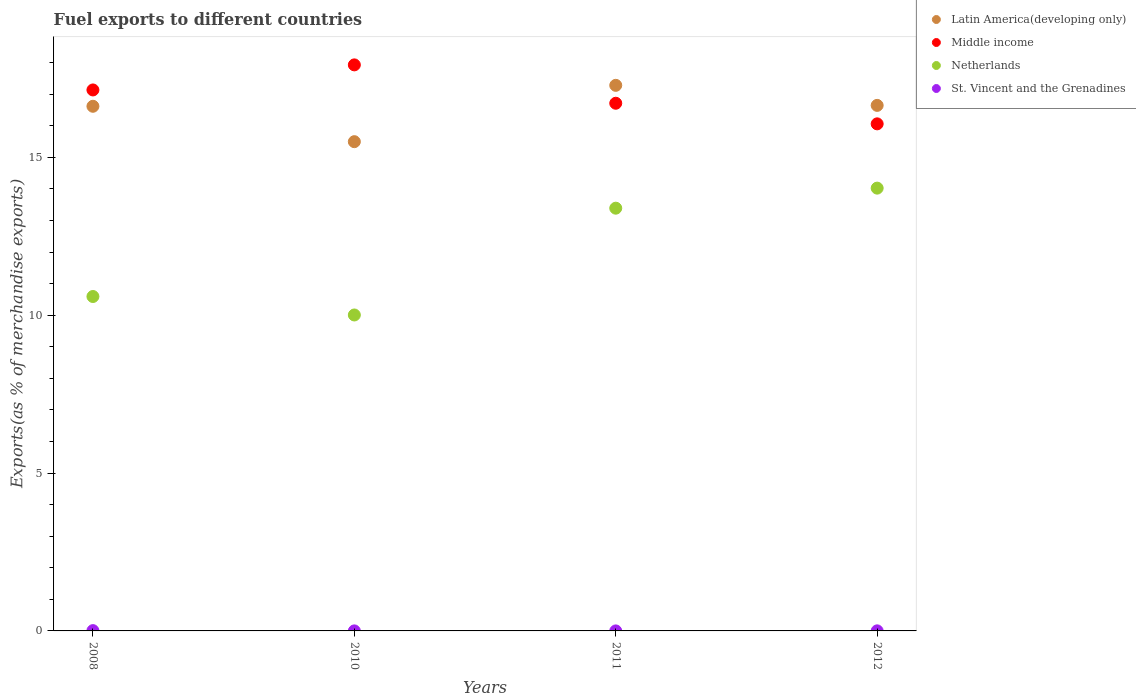What is the percentage of exports to different countries in Netherlands in 2011?
Make the answer very short. 13.39. Across all years, what is the maximum percentage of exports to different countries in Netherlands?
Your answer should be compact. 14.03. Across all years, what is the minimum percentage of exports to different countries in St. Vincent and the Grenadines?
Provide a succinct answer. 0. What is the total percentage of exports to different countries in St. Vincent and the Grenadines in the graph?
Your answer should be very brief. 0.01. What is the difference between the percentage of exports to different countries in Middle income in 2010 and that in 2011?
Your response must be concise. 1.22. What is the difference between the percentage of exports to different countries in St. Vincent and the Grenadines in 2008 and the percentage of exports to different countries in Middle income in 2010?
Ensure brevity in your answer.  -17.92. What is the average percentage of exports to different countries in Middle income per year?
Keep it short and to the point. 16.96. In the year 2008, what is the difference between the percentage of exports to different countries in Netherlands and percentage of exports to different countries in Middle income?
Keep it short and to the point. -6.54. What is the ratio of the percentage of exports to different countries in Netherlands in 2010 to that in 2012?
Provide a short and direct response. 0.71. Is the percentage of exports to different countries in St. Vincent and the Grenadines in 2008 less than that in 2012?
Your answer should be very brief. No. Is the difference between the percentage of exports to different countries in Netherlands in 2008 and 2012 greater than the difference between the percentage of exports to different countries in Middle income in 2008 and 2012?
Provide a succinct answer. No. What is the difference between the highest and the second highest percentage of exports to different countries in St. Vincent and the Grenadines?
Make the answer very short. 0.01. What is the difference between the highest and the lowest percentage of exports to different countries in Latin America(developing only)?
Give a very brief answer. 1.78. In how many years, is the percentage of exports to different countries in St. Vincent and the Grenadines greater than the average percentage of exports to different countries in St. Vincent and the Grenadines taken over all years?
Make the answer very short. 1. Is it the case that in every year, the sum of the percentage of exports to different countries in Netherlands and percentage of exports to different countries in Middle income  is greater than the sum of percentage of exports to different countries in Latin America(developing only) and percentage of exports to different countries in St. Vincent and the Grenadines?
Keep it short and to the point. No. Is it the case that in every year, the sum of the percentage of exports to different countries in Latin America(developing only) and percentage of exports to different countries in Middle income  is greater than the percentage of exports to different countries in St. Vincent and the Grenadines?
Offer a very short reply. Yes. Is the percentage of exports to different countries in Netherlands strictly greater than the percentage of exports to different countries in Latin America(developing only) over the years?
Your response must be concise. No. Is the percentage of exports to different countries in Middle income strictly less than the percentage of exports to different countries in Netherlands over the years?
Offer a terse response. No. How many dotlines are there?
Provide a succinct answer. 4. How many years are there in the graph?
Your answer should be compact. 4. Are the values on the major ticks of Y-axis written in scientific E-notation?
Ensure brevity in your answer.  No. How are the legend labels stacked?
Make the answer very short. Vertical. What is the title of the graph?
Keep it short and to the point. Fuel exports to different countries. Does "Dominican Republic" appear as one of the legend labels in the graph?
Your response must be concise. No. What is the label or title of the Y-axis?
Ensure brevity in your answer.  Exports(as % of merchandise exports). What is the Exports(as % of merchandise exports) in Latin America(developing only) in 2008?
Provide a succinct answer. 16.62. What is the Exports(as % of merchandise exports) of Middle income in 2008?
Give a very brief answer. 17.14. What is the Exports(as % of merchandise exports) in Netherlands in 2008?
Provide a short and direct response. 10.59. What is the Exports(as % of merchandise exports) in St. Vincent and the Grenadines in 2008?
Your answer should be compact. 0.01. What is the Exports(as % of merchandise exports) in Latin America(developing only) in 2010?
Your answer should be very brief. 15.5. What is the Exports(as % of merchandise exports) in Middle income in 2010?
Give a very brief answer. 17.93. What is the Exports(as % of merchandise exports) in Netherlands in 2010?
Give a very brief answer. 10.01. What is the Exports(as % of merchandise exports) of St. Vincent and the Grenadines in 2010?
Provide a succinct answer. 0. What is the Exports(as % of merchandise exports) of Latin America(developing only) in 2011?
Offer a terse response. 17.28. What is the Exports(as % of merchandise exports) of Middle income in 2011?
Ensure brevity in your answer.  16.72. What is the Exports(as % of merchandise exports) of Netherlands in 2011?
Offer a very short reply. 13.39. What is the Exports(as % of merchandise exports) in St. Vincent and the Grenadines in 2011?
Make the answer very short. 0. What is the Exports(as % of merchandise exports) of Latin America(developing only) in 2012?
Your response must be concise. 16.65. What is the Exports(as % of merchandise exports) in Middle income in 2012?
Provide a short and direct response. 16.06. What is the Exports(as % of merchandise exports) of Netherlands in 2012?
Give a very brief answer. 14.03. What is the Exports(as % of merchandise exports) of St. Vincent and the Grenadines in 2012?
Offer a terse response. 0. Across all years, what is the maximum Exports(as % of merchandise exports) of Latin America(developing only)?
Provide a short and direct response. 17.28. Across all years, what is the maximum Exports(as % of merchandise exports) in Middle income?
Keep it short and to the point. 17.93. Across all years, what is the maximum Exports(as % of merchandise exports) in Netherlands?
Offer a terse response. 14.03. Across all years, what is the maximum Exports(as % of merchandise exports) of St. Vincent and the Grenadines?
Provide a short and direct response. 0.01. Across all years, what is the minimum Exports(as % of merchandise exports) of Latin America(developing only)?
Your answer should be compact. 15.5. Across all years, what is the minimum Exports(as % of merchandise exports) in Middle income?
Your answer should be very brief. 16.06. Across all years, what is the minimum Exports(as % of merchandise exports) in Netherlands?
Provide a succinct answer. 10.01. Across all years, what is the minimum Exports(as % of merchandise exports) of St. Vincent and the Grenadines?
Give a very brief answer. 0. What is the total Exports(as % of merchandise exports) of Latin America(developing only) in the graph?
Your answer should be compact. 66.05. What is the total Exports(as % of merchandise exports) in Middle income in the graph?
Give a very brief answer. 67.85. What is the total Exports(as % of merchandise exports) of Netherlands in the graph?
Give a very brief answer. 48.02. What is the total Exports(as % of merchandise exports) of St. Vincent and the Grenadines in the graph?
Offer a very short reply. 0.01. What is the difference between the Exports(as % of merchandise exports) in Latin America(developing only) in 2008 and that in 2010?
Make the answer very short. 1.12. What is the difference between the Exports(as % of merchandise exports) of Middle income in 2008 and that in 2010?
Provide a succinct answer. -0.79. What is the difference between the Exports(as % of merchandise exports) of Netherlands in 2008 and that in 2010?
Ensure brevity in your answer.  0.59. What is the difference between the Exports(as % of merchandise exports) in St. Vincent and the Grenadines in 2008 and that in 2010?
Ensure brevity in your answer.  0.01. What is the difference between the Exports(as % of merchandise exports) of Latin America(developing only) in 2008 and that in 2011?
Provide a succinct answer. -0.66. What is the difference between the Exports(as % of merchandise exports) in Middle income in 2008 and that in 2011?
Your response must be concise. 0.42. What is the difference between the Exports(as % of merchandise exports) of Netherlands in 2008 and that in 2011?
Your response must be concise. -2.8. What is the difference between the Exports(as % of merchandise exports) of St. Vincent and the Grenadines in 2008 and that in 2011?
Your answer should be very brief. 0.01. What is the difference between the Exports(as % of merchandise exports) of Latin America(developing only) in 2008 and that in 2012?
Offer a terse response. -0.03. What is the difference between the Exports(as % of merchandise exports) of Middle income in 2008 and that in 2012?
Offer a terse response. 1.07. What is the difference between the Exports(as % of merchandise exports) in Netherlands in 2008 and that in 2012?
Ensure brevity in your answer.  -3.43. What is the difference between the Exports(as % of merchandise exports) in St. Vincent and the Grenadines in 2008 and that in 2012?
Your answer should be compact. 0.01. What is the difference between the Exports(as % of merchandise exports) in Latin America(developing only) in 2010 and that in 2011?
Ensure brevity in your answer.  -1.78. What is the difference between the Exports(as % of merchandise exports) in Middle income in 2010 and that in 2011?
Make the answer very short. 1.22. What is the difference between the Exports(as % of merchandise exports) of Netherlands in 2010 and that in 2011?
Provide a succinct answer. -3.38. What is the difference between the Exports(as % of merchandise exports) of St. Vincent and the Grenadines in 2010 and that in 2011?
Offer a very short reply. 0. What is the difference between the Exports(as % of merchandise exports) of Latin America(developing only) in 2010 and that in 2012?
Provide a succinct answer. -1.15. What is the difference between the Exports(as % of merchandise exports) of Middle income in 2010 and that in 2012?
Make the answer very short. 1.87. What is the difference between the Exports(as % of merchandise exports) in Netherlands in 2010 and that in 2012?
Give a very brief answer. -4.02. What is the difference between the Exports(as % of merchandise exports) in St. Vincent and the Grenadines in 2010 and that in 2012?
Provide a succinct answer. -0. What is the difference between the Exports(as % of merchandise exports) of Latin America(developing only) in 2011 and that in 2012?
Ensure brevity in your answer.  0.64. What is the difference between the Exports(as % of merchandise exports) in Middle income in 2011 and that in 2012?
Your response must be concise. 0.65. What is the difference between the Exports(as % of merchandise exports) in Netherlands in 2011 and that in 2012?
Provide a short and direct response. -0.64. What is the difference between the Exports(as % of merchandise exports) in St. Vincent and the Grenadines in 2011 and that in 2012?
Keep it short and to the point. -0. What is the difference between the Exports(as % of merchandise exports) in Latin America(developing only) in 2008 and the Exports(as % of merchandise exports) in Middle income in 2010?
Give a very brief answer. -1.31. What is the difference between the Exports(as % of merchandise exports) in Latin America(developing only) in 2008 and the Exports(as % of merchandise exports) in Netherlands in 2010?
Your answer should be compact. 6.61. What is the difference between the Exports(as % of merchandise exports) in Latin America(developing only) in 2008 and the Exports(as % of merchandise exports) in St. Vincent and the Grenadines in 2010?
Offer a very short reply. 16.62. What is the difference between the Exports(as % of merchandise exports) of Middle income in 2008 and the Exports(as % of merchandise exports) of Netherlands in 2010?
Keep it short and to the point. 7.13. What is the difference between the Exports(as % of merchandise exports) of Middle income in 2008 and the Exports(as % of merchandise exports) of St. Vincent and the Grenadines in 2010?
Ensure brevity in your answer.  17.14. What is the difference between the Exports(as % of merchandise exports) of Netherlands in 2008 and the Exports(as % of merchandise exports) of St. Vincent and the Grenadines in 2010?
Your answer should be very brief. 10.59. What is the difference between the Exports(as % of merchandise exports) in Latin America(developing only) in 2008 and the Exports(as % of merchandise exports) in Middle income in 2011?
Offer a terse response. -0.1. What is the difference between the Exports(as % of merchandise exports) of Latin America(developing only) in 2008 and the Exports(as % of merchandise exports) of Netherlands in 2011?
Your answer should be compact. 3.23. What is the difference between the Exports(as % of merchandise exports) of Latin America(developing only) in 2008 and the Exports(as % of merchandise exports) of St. Vincent and the Grenadines in 2011?
Ensure brevity in your answer.  16.62. What is the difference between the Exports(as % of merchandise exports) of Middle income in 2008 and the Exports(as % of merchandise exports) of Netherlands in 2011?
Provide a succinct answer. 3.75. What is the difference between the Exports(as % of merchandise exports) in Middle income in 2008 and the Exports(as % of merchandise exports) in St. Vincent and the Grenadines in 2011?
Offer a terse response. 17.14. What is the difference between the Exports(as % of merchandise exports) in Netherlands in 2008 and the Exports(as % of merchandise exports) in St. Vincent and the Grenadines in 2011?
Offer a very short reply. 10.59. What is the difference between the Exports(as % of merchandise exports) in Latin America(developing only) in 2008 and the Exports(as % of merchandise exports) in Middle income in 2012?
Keep it short and to the point. 0.56. What is the difference between the Exports(as % of merchandise exports) of Latin America(developing only) in 2008 and the Exports(as % of merchandise exports) of Netherlands in 2012?
Provide a short and direct response. 2.59. What is the difference between the Exports(as % of merchandise exports) in Latin America(developing only) in 2008 and the Exports(as % of merchandise exports) in St. Vincent and the Grenadines in 2012?
Keep it short and to the point. 16.62. What is the difference between the Exports(as % of merchandise exports) in Middle income in 2008 and the Exports(as % of merchandise exports) in Netherlands in 2012?
Your response must be concise. 3.11. What is the difference between the Exports(as % of merchandise exports) in Middle income in 2008 and the Exports(as % of merchandise exports) in St. Vincent and the Grenadines in 2012?
Give a very brief answer. 17.14. What is the difference between the Exports(as % of merchandise exports) in Netherlands in 2008 and the Exports(as % of merchandise exports) in St. Vincent and the Grenadines in 2012?
Provide a short and direct response. 10.59. What is the difference between the Exports(as % of merchandise exports) in Latin America(developing only) in 2010 and the Exports(as % of merchandise exports) in Middle income in 2011?
Provide a short and direct response. -1.22. What is the difference between the Exports(as % of merchandise exports) in Latin America(developing only) in 2010 and the Exports(as % of merchandise exports) in Netherlands in 2011?
Your answer should be very brief. 2.11. What is the difference between the Exports(as % of merchandise exports) in Latin America(developing only) in 2010 and the Exports(as % of merchandise exports) in St. Vincent and the Grenadines in 2011?
Offer a very short reply. 15.5. What is the difference between the Exports(as % of merchandise exports) of Middle income in 2010 and the Exports(as % of merchandise exports) of Netherlands in 2011?
Make the answer very short. 4.54. What is the difference between the Exports(as % of merchandise exports) in Middle income in 2010 and the Exports(as % of merchandise exports) in St. Vincent and the Grenadines in 2011?
Offer a terse response. 17.93. What is the difference between the Exports(as % of merchandise exports) in Netherlands in 2010 and the Exports(as % of merchandise exports) in St. Vincent and the Grenadines in 2011?
Your response must be concise. 10.01. What is the difference between the Exports(as % of merchandise exports) in Latin America(developing only) in 2010 and the Exports(as % of merchandise exports) in Middle income in 2012?
Provide a succinct answer. -0.56. What is the difference between the Exports(as % of merchandise exports) in Latin America(developing only) in 2010 and the Exports(as % of merchandise exports) in Netherlands in 2012?
Your answer should be very brief. 1.47. What is the difference between the Exports(as % of merchandise exports) in Latin America(developing only) in 2010 and the Exports(as % of merchandise exports) in St. Vincent and the Grenadines in 2012?
Your answer should be compact. 15.5. What is the difference between the Exports(as % of merchandise exports) in Middle income in 2010 and the Exports(as % of merchandise exports) in Netherlands in 2012?
Your answer should be compact. 3.9. What is the difference between the Exports(as % of merchandise exports) of Middle income in 2010 and the Exports(as % of merchandise exports) of St. Vincent and the Grenadines in 2012?
Your answer should be compact. 17.93. What is the difference between the Exports(as % of merchandise exports) of Netherlands in 2010 and the Exports(as % of merchandise exports) of St. Vincent and the Grenadines in 2012?
Make the answer very short. 10.01. What is the difference between the Exports(as % of merchandise exports) in Latin America(developing only) in 2011 and the Exports(as % of merchandise exports) in Middle income in 2012?
Give a very brief answer. 1.22. What is the difference between the Exports(as % of merchandise exports) in Latin America(developing only) in 2011 and the Exports(as % of merchandise exports) in Netherlands in 2012?
Your answer should be compact. 3.26. What is the difference between the Exports(as % of merchandise exports) of Latin America(developing only) in 2011 and the Exports(as % of merchandise exports) of St. Vincent and the Grenadines in 2012?
Make the answer very short. 17.28. What is the difference between the Exports(as % of merchandise exports) in Middle income in 2011 and the Exports(as % of merchandise exports) in Netherlands in 2012?
Your answer should be very brief. 2.69. What is the difference between the Exports(as % of merchandise exports) of Middle income in 2011 and the Exports(as % of merchandise exports) of St. Vincent and the Grenadines in 2012?
Provide a short and direct response. 16.71. What is the difference between the Exports(as % of merchandise exports) in Netherlands in 2011 and the Exports(as % of merchandise exports) in St. Vincent and the Grenadines in 2012?
Offer a very short reply. 13.39. What is the average Exports(as % of merchandise exports) in Latin America(developing only) per year?
Give a very brief answer. 16.51. What is the average Exports(as % of merchandise exports) in Middle income per year?
Provide a succinct answer. 16.96. What is the average Exports(as % of merchandise exports) of Netherlands per year?
Provide a succinct answer. 12.01. What is the average Exports(as % of merchandise exports) of St. Vincent and the Grenadines per year?
Your response must be concise. 0. In the year 2008, what is the difference between the Exports(as % of merchandise exports) of Latin America(developing only) and Exports(as % of merchandise exports) of Middle income?
Offer a terse response. -0.52. In the year 2008, what is the difference between the Exports(as % of merchandise exports) of Latin America(developing only) and Exports(as % of merchandise exports) of Netherlands?
Offer a terse response. 6.03. In the year 2008, what is the difference between the Exports(as % of merchandise exports) of Latin America(developing only) and Exports(as % of merchandise exports) of St. Vincent and the Grenadines?
Give a very brief answer. 16.61. In the year 2008, what is the difference between the Exports(as % of merchandise exports) in Middle income and Exports(as % of merchandise exports) in Netherlands?
Give a very brief answer. 6.54. In the year 2008, what is the difference between the Exports(as % of merchandise exports) in Middle income and Exports(as % of merchandise exports) in St. Vincent and the Grenadines?
Give a very brief answer. 17.13. In the year 2008, what is the difference between the Exports(as % of merchandise exports) of Netherlands and Exports(as % of merchandise exports) of St. Vincent and the Grenadines?
Your response must be concise. 10.59. In the year 2010, what is the difference between the Exports(as % of merchandise exports) of Latin America(developing only) and Exports(as % of merchandise exports) of Middle income?
Your answer should be compact. -2.43. In the year 2010, what is the difference between the Exports(as % of merchandise exports) in Latin America(developing only) and Exports(as % of merchandise exports) in Netherlands?
Provide a succinct answer. 5.49. In the year 2010, what is the difference between the Exports(as % of merchandise exports) in Latin America(developing only) and Exports(as % of merchandise exports) in St. Vincent and the Grenadines?
Provide a short and direct response. 15.5. In the year 2010, what is the difference between the Exports(as % of merchandise exports) of Middle income and Exports(as % of merchandise exports) of Netherlands?
Provide a short and direct response. 7.92. In the year 2010, what is the difference between the Exports(as % of merchandise exports) of Middle income and Exports(as % of merchandise exports) of St. Vincent and the Grenadines?
Your answer should be very brief. 17.93. In the year 2010, what is the difference between the Exports(as % of merchandise exports) of Netherlands and Exports(as % of merchandise exports) of St. Vincent and the Grenadines?
Make the answer very short. 10.01. In the year 2011, what is the difference between the Exports(as % of merchandise exports) in Latin America(developing only) and Exports(as % of merchandise exports) in Middle income?
Your response must be concise. 0.57. In the year 2011, what is the difference between the Exports(as % of merchandise exports) in Latin America(developing only) and Exports(as % of merchandise exports) in Netherlands?
Your answer should be very brief. 3.89. In the year 2011, what is the difference between the Exports(as % of merchandise exports) in Latin America(developing only) and Exports(as % of merchandise exports) in St. Vincent and the Grenadines?
Give a very brief answer. 17.28. In the year 2011, what is the difference between the Exports(as % of merchandise exports) of Middle income and Exports(as % of merchandise exports) of Netherlands?
Offer a terse response. 3.32. In the year 2011, what is the difference between the Exports(as % of merchandise exports) in Middle income and Exports(as % of merchandise exports) in St. Vincent and the Grenadines?
Make the answer very short. 16.72. In the year 2011, what is the difference between the Exports(as % of merchandise exports) of Netherlands and Exports(as % of merchandise exports) of St. Vincent and the Grenadines?
Ensure brevity in your answer.  13.39. In the year 2012, what is the difference between the Exports(as % of merchandise exports) in Latin America(developing only) and Exports(as % of merchandise exports) in Middle income?
Your answer should be compact. 0.58. In the year 2012, what is the difference between the Exports(as % of merchandise exports) of Latin America(developing only) and Exports(as % of merchandise exports) of Netherlands?
Make the answer very short. 2.62. In the year 2012, what is the difference between the Exports(as % of merchandise exports) in Latin America(developing only) and Exports(as % of merchandise exports) in St. Vincent and the Grenadines?
Keep it short and to the point. 16.65. In the year 2012, what is the difference between the Exports(as % of merchandise exports) in Middle income and Exports(as % of merchandise exports) in Netherlands?
Offer a very short reply. 2.04. In the year 2012, what is the difference between the Exports(as % of merchandise exports) of Middle income and Exports(as % of merchandise exports) of St. Vincent and the Grenadines?
Your answer should be very brief. 16.06. In the year 2012, what is the difference between the Exports(as % of merchandise exports) of Netherlands and Exports(as % of merchandise exports) of St. Vincent and the Grenadines?
Provide a succinct answer. 14.03. What is the ratio of the Exports(as % of merchandise exports) of Latin America(developing only) in 2008 to that in 2010?
Your response must be concise. 1.07. What is the ratio of the Exports(as % of merchandise exports) in Middle income in 2008 to that in 2010?
Ensure brevity in your answer.  0.96. What is the ratio of the Exports(as % of merchandise exports) of Netherlands in 2008 to that in 2010?
Offer a terse response. 1.06. What is the ratio of the Exports(as % of merchandise exports) of St. Vincent and the Grenadines in 2008 to that in 2010?
Offer a very short reply. 9.34. What is the ratio of the Exports(as % of merchandise exports) in Latin America(developing only) in 2008 to that in 2011?
Give a very brief answer. 0.96. What is the ratio of the Exports(as % of merchandise exports) of Middle income in 2008 to that in 2011?
Provide a short and direct response. 1.03. What is the ratio of the Exports(as % of merchandise exports) in Netherlands in 2008 to that in 2011?
Offer a very short reply. 0.79. What is the ratio of the Exports(as % of merchandise exports) in St. Vincent and the Grenadines in 2008 to that in 2011?
Keep it short and to the point. 22.86. What is the ratio of the Exports(as % of merchandise exports) of Middle income in 2008 to that in 2012?
Provide a short and direct response. 1.07. What is the ratio of the Exports(as % of merchandise exports) in Netherlands in 2008 to that in 2012?
Provide a short and direct response. 0.76. What is the ratio of the Exports(as % of merchandise exports) in St. Vincent and the Grenadines in 2008 to that in 2012?
Offer a terse response. 4.32. What is the ratio of the Exports(as % of merchandise exports) of Latin America(developing only) in 2010 to that in 2011?
Provide a short and direct response. 0.9. What is the ratio of the Exports(as % of merchandise exports) of Middle income in 2010 to that in 2011?
Offer a terse response. 1.07. What is the ratio of the Exports(as % of merchandise exports) of Netherlands in 2010 to that in 2011?
Your answer should be compact. 0.75. What is the ratio of the Exports(as % of merchandise exports) in St. Vincent and the Grenadines in 2010 to that in 2011?
Provide a succinct answer. 2.45. What is the ratio of the Exports(as % of merchandise exports) of Latin America(developing only) in 2010 to that in 2012?
Your response must be concise. 0.93. What is the ratio of the Exports(as % of merchandise exports) in Middle income in 2010 to that in 2012?
Offer a very short reply. 1.12. What is the ratio of the Exports(as % of merchandise exports) in Netherlands in 2010 to that in 2012?
Give a very brief answer. 0.71. What is the ratio of the Exports(as % of merchandise exports) of St. Vincent and the Grenadines in 2010 to that in 2012?
Keep it short and to the point. 0.46. What is the ratio of the Exports(as % of merchandise exports) of Latin America(developing only) in 2011 to that in 2012?
Offer a very short reply. 1.04. What is the ratio of the Exports(as % of merchandise exports) of Middle income in 2011 to that in 2012?
Give a very brief answer. 1.04. What is the ratio of the Exports(as % of merchandise exports) of Netherlands in 2011 to that in 2012?
Make the answer very short. 0.95. What is the ratio of the Exports(as % of merchandise exports) in St. Vincent and the Grenadines in 2011 to that in 2012?
Offer a terse response. 0.19. What is the difference between the highest and the second highest Exports(as % of merchandise exports) of Latin America(developing only)?
Ensure brevity in your answer.  0.64. What is the difference between the highest and the second highest Exports(as % of merchandise exports) in Middle income?
Provide a succinct answer. 0.79. What is the difference between the highest and the second highest Exports(as % of merchandise exports) of Netherlands?
Your response must be concise. 0.64. What is the difference between the highest and the second highest Exports(as % of merchandise exports) of St. Vincent and the Grenadines?
Keep it short and to the point. 0.01. What is the difference between the highest and the lowest Exports(as % of merchandise exports) of Latin America(developing only)?
Provide a succinct answer. 1.78. What is the difference between the highest and the lowest Exports(as % of merchandise exports) in Middle income?
Ensure brevity in your answer.  1.87. What is the difference between the highest and the lowest Exports(as % of merchandise exports) in Netherlands?
Your answer should be compact. 4.02. What is the difference between the highest and the lowest Exports(as % of merchandise exports) in St. Vincent and the Grenadines?
Give a very brief answer. 0.01. 